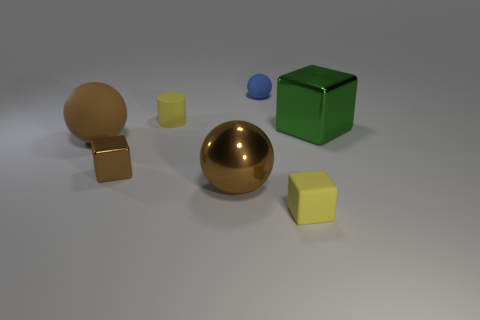Subtract all brown spheres. Subtract all blue blocks. How many spheres are left? 1 Add 2 yellow blocks. How many objects exist? 9 Subtract all cubes. How many objects are left? 4 Add 7 tiny yellow metal spheres. How many tiny yellow metal spheres exist? 7 Subtract 0 gray balls. How many objects are left? 7 Subtract all large rubber spheres. Subtract all big green cubes. How many objects are left? 5 Add 2 blue rubber spheres. How many blue rubber spheres are left? 3 